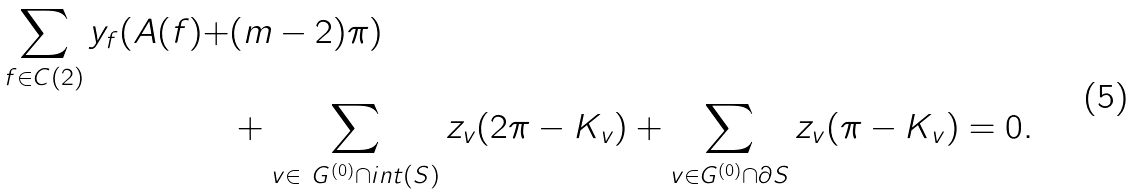<formula> <loc_0><loc_0><loc_500><loc_500>\sum _ { f \in C ( 2 ) } y _ { f } ( A ( f ) + & ( m - 2 ) \pi ) \\ & + \sum _ { v \in \ G ^ { ( 0 ) } \cap i n t ( S ) } z _ { v } ( 2 \pi - K _ { v } ) + \sum _ { v \in G ^ { ( 0 ) } \cap \partial S } z _ { v } ( \pi - K _ { v } ) = 0 .</formula> 